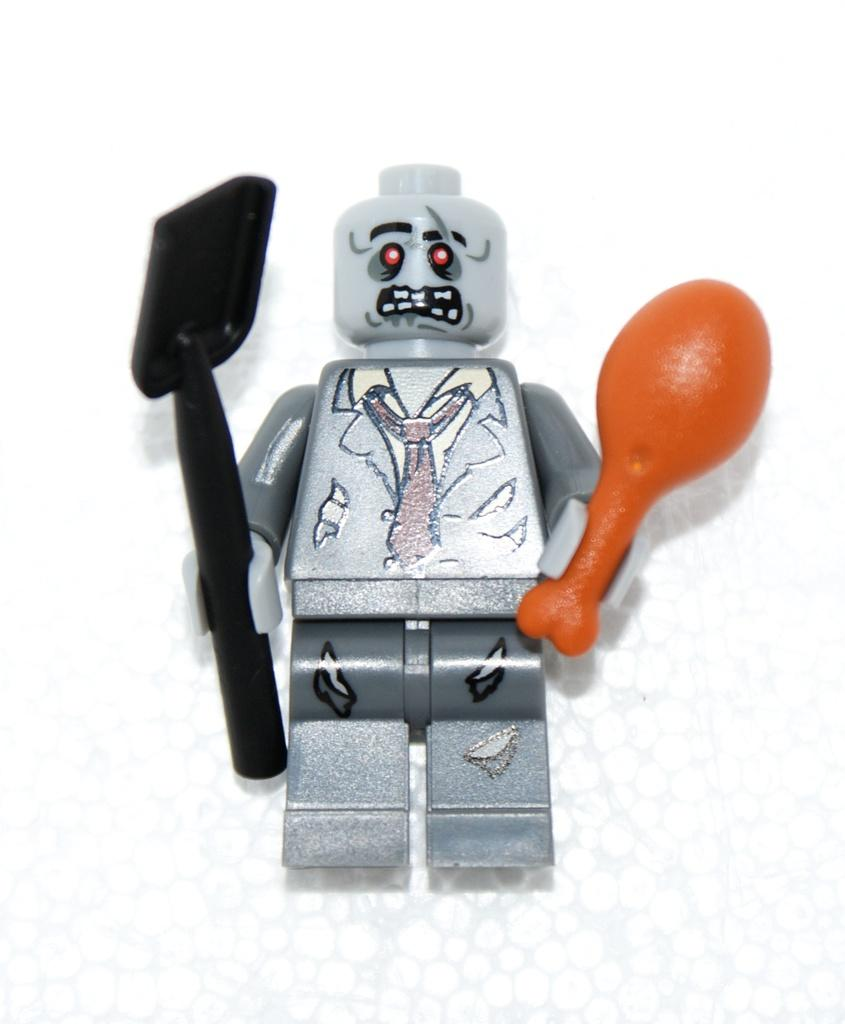What is the main subject of the image? There is a doll in the image. What is the doll holding in its hand? The doll is holding a plastic balloon and a spoon. What type of honey is the doll drizzling on the pancakes in the image? There are no pancakes or honey present in the image; it features a doll holding a plastic balloon and a spoon. 